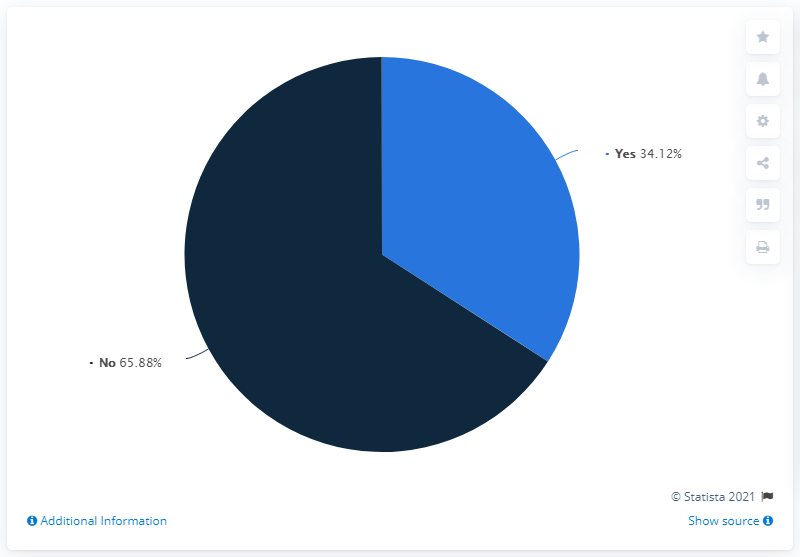Draw attention to some important aspects in this diagram. It is estimated that 34.12% of individuals desire to remain informed and up-to-date. The ratio of yes to no is approximately 0.518. 